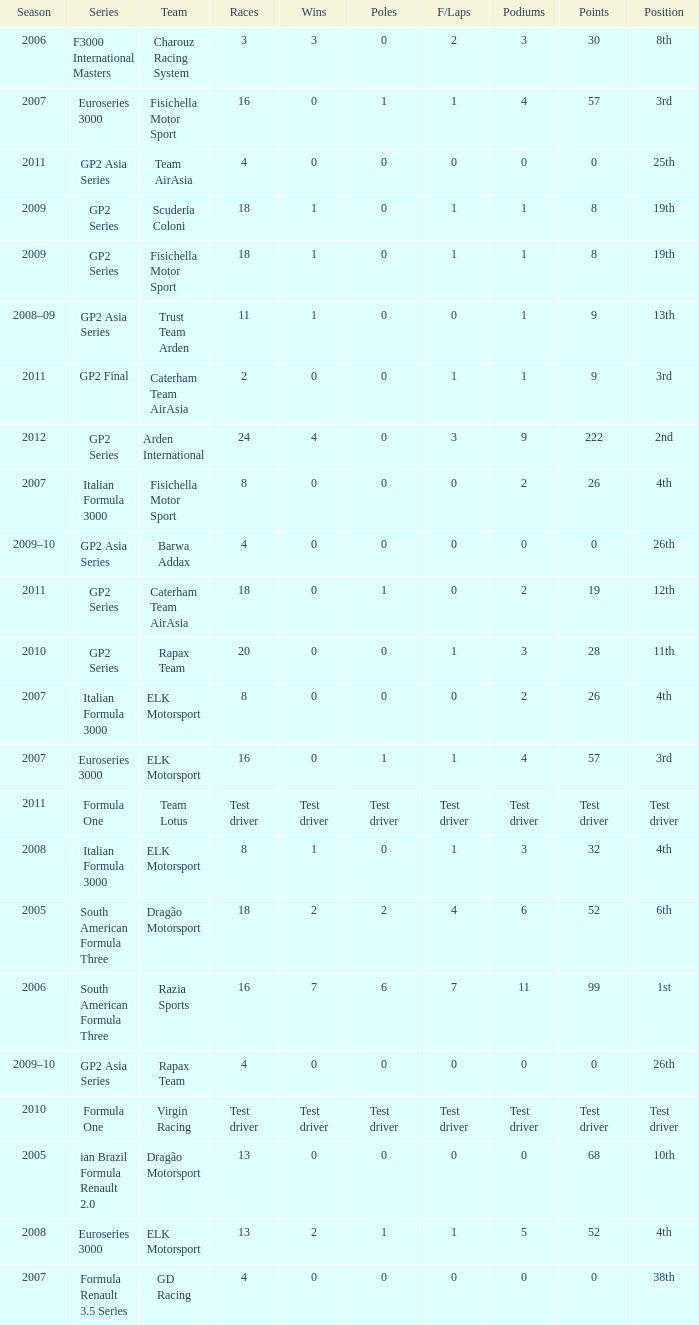How many races did he do in the year he had 8 points? 18, 18. Could you parse the entire table as a dict? {'header': ['Season', 'Series', 'Team', 'Races', 'Wins', 'Poles', 'F/Laps', 'Podiums', 'Points', 'Position'], 'rows': [['2006', 'F3000 International Masters', 'Charouz Racing System', '3', '3', '0', '2', '3', '30', '8th'], ['2007', 'Euroseries 3000', 'Fisichella Motor Sport', '16', '0', '1', '1', '4', '57', '3rd'], ['2011', 'GP2 Asia Series', 'Team AirAsia', '4', '0', '0', '0', '0', '0', '25th'], ['2009', 'GP2 Series', 'Scuderia Coloni', '18', '1', '0', '1', '1', '8', '19th'], ['2009', 'GP2 Series', 'Fisichella Motor Sport', '18', '1', '0', '1', '1', '8', '19th'], ['2008–09', 'GP2 Asia Series', 'Trust Team Arden', '11', '1', '0', '0', '1', '9', '13th'], ['2011', 'GP2 Final', 'Caterham Team AirAsia', '2', '0', '0', '1', '1', '9', '3rd'], ['2012', 'GP2 Series', 'Arden International', '24', '4', '0', '3', '9', '222', '2nd'], ['2007', 'Italian Formula 3000', 'Fisichella Motor Sport', '8', '0', '0', '0', '2', '26', '4th'], ['2009–10', 'GP2 Asia Series', 'Barwa Addax', '4', '0', '0', '0', '0', '0', '26th'], ['2011', 'GP2 Series', 'Caterham Team AirAsia', '18', '0', '1', '0', '2', '19', '12th'], ['2010', 'GP2 Series', 'Rapax Team', '20', '0', '0', '1', '3', '28', '11th'], ['2007', 'Italian Formula 3000', 'ELK Motorsport', '8', '0', '0', '0', '2', '26', '4th'], ['2007', 'Euroseries 3000', 'ELK Motorsport', '16', '0', '1', '1', '4', '57', '3rd'], ['2011', 'Formula One', 'Team Lotus', 'Test driver', 'Test driver', 'Test driver', 'Test driver', 'Test driver', 'Test driver', 'Test driver'], ['2008', 'Italian Formula 3000', 'ELK Motorsport', '8', '1', '0', '1', '3', '32', '4th'], ['2005', 'South American Formula Three', 'Dragão Motorsport', '18', '2', '2', '4', '6', '52', '6th'], ['2006', 'South American Formula Three', 'Razia Sports', '16', '7', '6', '7', '11', '99', '1st'], ['2009–10', 'GP2 Asia Series', 'Rapax Team', '4', '0', '0', '0', '0', '0', '26th'], ['2010', 'Formula One', 'Virgin Racing', 'Test driver', 'Test driver', 'Test driver', 'Test driver', 'Test driver', 'Test driver', 'Test driver'], ['2005', 'ian Brazil Formula Renault 2.0', 'Dragão Motorsport', '13', '0', '0', '0', '0', '68', '10th'], ['2008', 'Euroseries 3000', 'ELK Motorsport', '13', '2', '1', '1', '5', '52', '4th'], ['2007', 'Formula Renault 3.5 Series', 'GD Racing', '4', '0', '0', '0', '0', '0', '38th']]} 